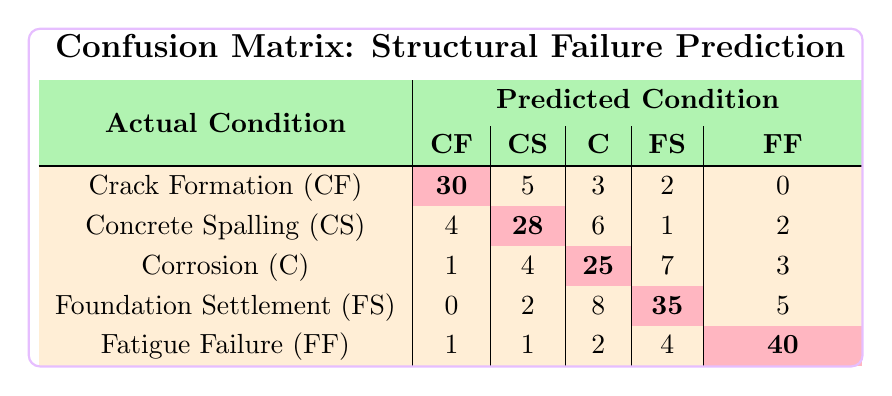What is the predicted number of Crack Formation cases when they actually occurred? Looking at the row for Crack Formation, the predicted number is indicated in the corresponding cell, which shows 30.
Answer: 30 What is the number of times Concrete Spalling was incorrectly predicted as Corrosion? From the row for Concrete Spalling, the number predicted incorrectly as Corrosion is 6.
Answer: 6 What is the total number of Foundation Settlement occurrences predicted across all actual conditions? To find the total for Foundation Settlement, sum the values in the FS column: 2 + 1 + 7 + 35 + 4 = 49.
Answer: 49 Is there any case where Fatigue Failure was predicted as Crack Formation? In the Fatigue Failure row, the predicted cases for Crack Formation is 1, which indicates it was predicted as such.
Answer: Yes What is the overall accuracy for predicting Fatigue Failure? To calculate accuracy for Fatigue Failure, we take the predicted correctly (40) and divide it by the total actual occurrences (40 + 1 + 2 + 4 + 1 = 48). Thus, the accuracy is 40/48 = 0.8333 or about 83.33%.
Answer: 83.33% Which failure type had the most incorrect predictions in total? To find this, we look at the total misclassifications for each category: For Crack Formation: 5 + 3 + 2 + 0 = 10; Concrete Spalling: 4 + 6 + 1 + 2 = 13; Corrosion: 1 + 4 + 7 + 3 = 15; Foundation Settlement: 0 + 2 + 8 + 5 = 15; Fatigue Failure: 1 + 1 + 2 + 4 = 8. The highest total is 15 for Corrosion and Foundation Settlement.
Answer: Corrosion and Foundation Settlement What is the difference between the count of correct predictions for Concrete Spalling and Foundation Settlement? The correct predictions are 28 for Concrete Spalling and 35 for Foundation Settlement. The difference is calculated as 35 - 28 = 7.
Answer: 7 How many cases were predicted incorrectly overall? To find this, we sum up all incorrect predictions in the matrix. This includes all the values not on the diagonal. Total incorrect predictions: 5 + 3 + 2 + 0 + 4 + 6 + 1 + 2 + 1 + 2 + 4 + 8 + 5 + 1 + 2 + 4 = 54.
Answer: 54 What is the proportion of cases where Corrosion was correctly predicted? The correct predictions for Corrosion are 25, and the total occurrences for Corrosion are (1 + 4 + 25 + 7 + 3) = 40. Therefore, the proportion is 25/40 = 0.625 or 62.5%.
Answer: 62.5% 